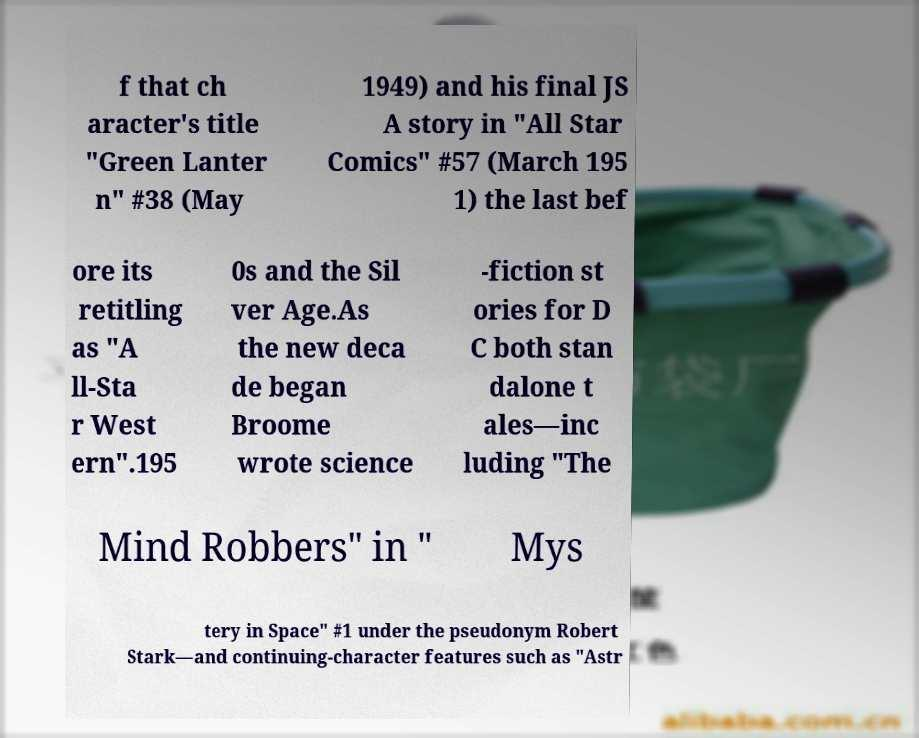Could you extract and type out the text from this image? f that ch aracter's title "Green Lanter n" #38 (May 1949) and his final JS A story in "All Star Comics" #57 (March 195 1) the last bef ore its retitling as "A ll-Sta r West ern".195 0s and the Sil ver Age.As the new deca de began Broome wrote science -fiction st ories for D C both stan dalone t ales—inc luding "The Mind Robbers" in " Mys tery in Space" #1 under the pseudonym Robert Stark—and continuing-character features such as "Astr 